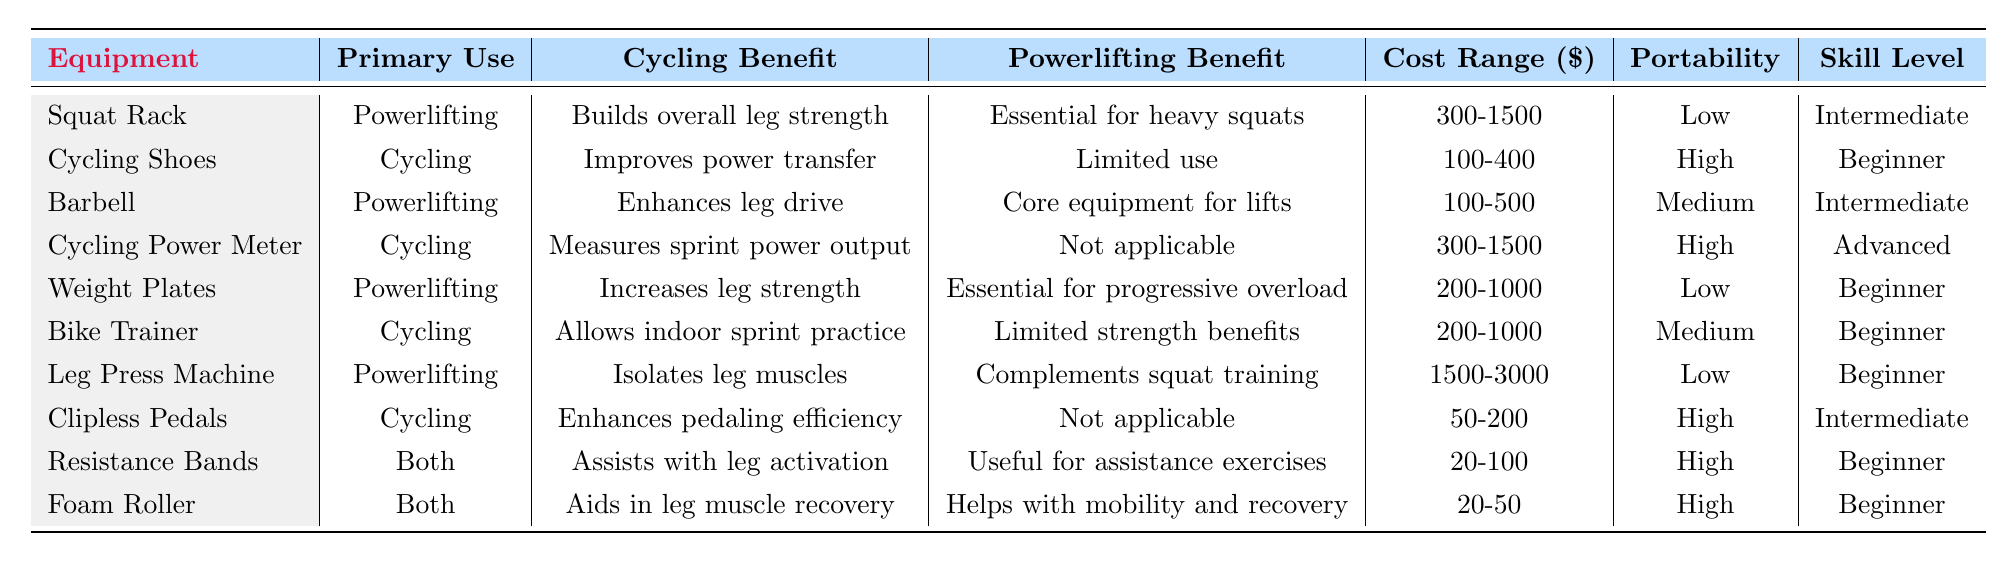What is the cost range for a Squat Rack? The table indicates the cost range for a Squat Rack is listed in the "Cost Range ($)" column, which is 300-1500.
Answer: 300-1500 Which equipment has the highest cost range? By comparing the "Cost Range ($)" values for all equipment, the Leg Press Machine has the highest range listed at 1500-3000.
Answer: Leg Press Machine Do Cycling Shoes provide significant benefits for powerlifting? Checking the "Powerlifting Benefit" column for Cycling Shoes shows "Limited use," indicating they do not provide significant benefits for powerlifting.
Answer: No How many equipment types are portable? By assessing the "Portability" column, four items are classified as "High" in portability (Cycling Shoes, Cycling Power Meter, Clipless Pedals, Resistance Bands, Foam Roller). Thus, total count is 5.
Answer: 5 Is a Barbell essential for powerlifting? The "Powerlifting Benefit" column states that a Barbell is "Core equipment for lifts," indicating it is essential for powerlifting.
Answer: Yes What is the average cost range of cycling gear (Cycling Shoes, Cycling Power Meter, Bike Trainer, Clipless Pedals)? The cost ranges for cycling gear are 100-400, 300-1500, 200-1000, and 50-200. The approximate values are 250, 900, 600, and 125 respectively. Average is (250 + 900 + 600 + 125) / 4 = 978 / 4 = 244.5.
Answer: 244.5 Which equipment has a low portability rating but is essential for progressive overload? By checking the "Portability" ratings and "Powerlifting Benefit", Weight Plates have a "Low" portability rating and are "Essential for progressive overload."
Answer: Weight Plates What is the primary use of a Bike Trainer as per the table? The "Primary Use" column specifies that a Bike Trainer is categorized under Cycling.
Answer: Cycling Which equipment is suitable for beginners and aids in leg muscle recovery? The Foam Roller is identified as suitable for beginners and is mentioned to aid in leg muscle recovery in the "Cycling Benefit" column.
Answer: Foam Roller Can Resistance Bands be used for both cycling and powerlifting? The "Primary Use" column states "Both," confirming that Resistance Bands can indeed be used for both cycling and powerlifting.
Answer: Yes 